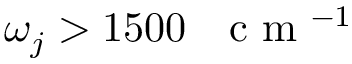<formula> <loc_0><loc_0><loc_500><loc_500>\omega _ { j } > 1 5 0 0 c m ^ { - 1 }</formula> 